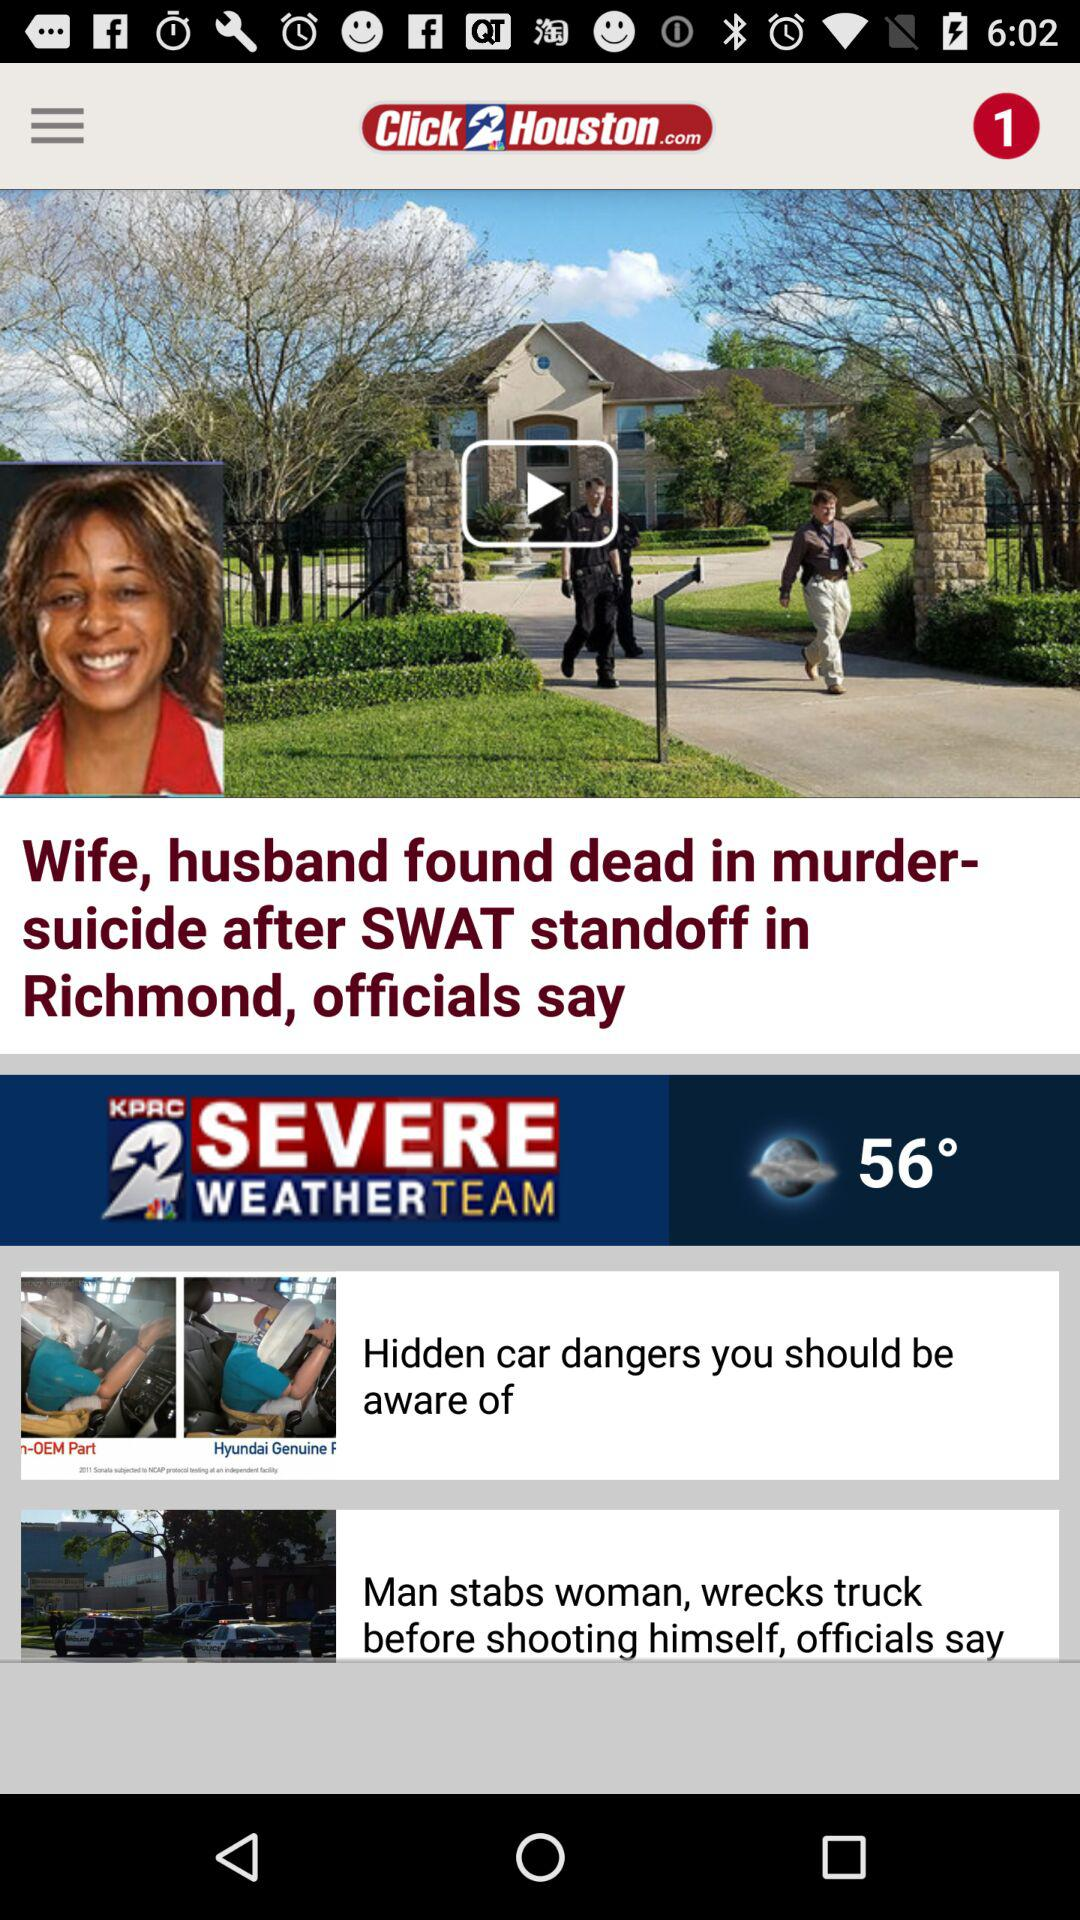What is the temperature? The temperature is 56°. 